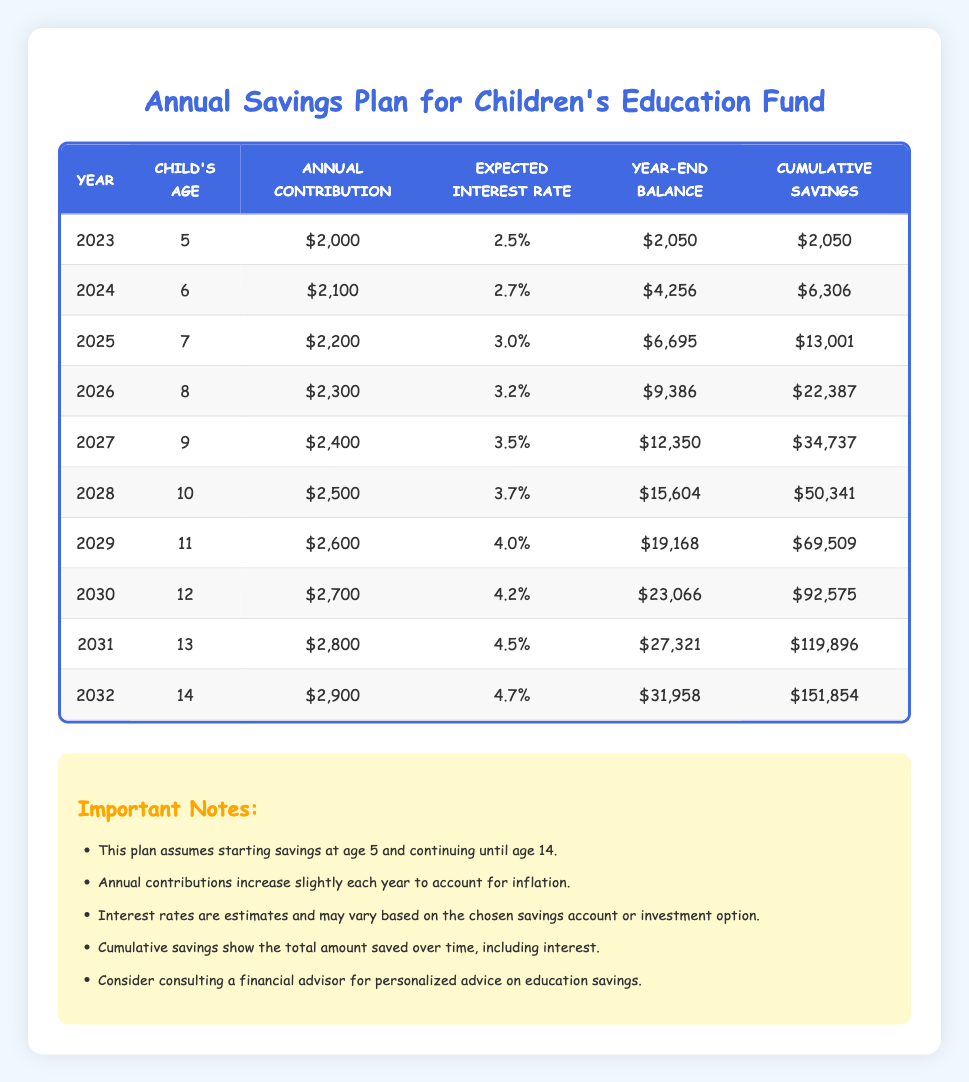What is the child's age in 2027? In the table, the row for the year 2027 shows the child's age is listed as 9.
Answer: 9 What is the cumulative savings in 2028? The cumulative savings for the year 2028 is directly provided in the table, which states it as 50,341.
Answer: 50,341 How much did the annual contribution increase from 2023 to 2024? The annual contribution in 2023 is 2,000, and in 2024 it is 2,100. The difference is 2,100 - 2,000 = 100.
Answer: 100 What is the expected interest rate for 2031? The expected interest rate for the year 2031 is given in the table as 4.5%.
Answer: 4.5% What is the cumulative savings for the year 2032 compared to that of 2026? The cumulative savings for 2032 is 151,854 and for 2026 it is 22,387. The difference is 151,854 - 22,387 = 129,467.
Answer: 129,467 Did the annual contribution always increase each year? By reviewing the annual contributions shown in the table for each year (2,000 to 2,900), we find that each value is greater than the previous, confirming that the contributions always increased.
Answer: Yes What is the total expected interest rate from 2023 to 2032? To find the total expected interest rates, we need to sum up the rates from the table: 2.5 + 2.7 + 3.0 + 3.2 + 3.5 + 3.7 + 4.0 + 4.2 + 4.5 + 4.7 = 36.0%.
Answer: 36.0% What was the year-end balance in 2029? In the 2029 row of the table, the year-end balance is listed as 19,168.
Answer: 19,168 How much did the year-end balance increase from 2025 to 2026? For 2025, the year-end balance is 6,695, and for 2026, it is 9,386. The increase is 9,386 - 6,695 = 2,691.
Answer: 2,691 Which year had the highest annual contribution, and how much was it? The highest annual contribution is seen in 2032, where it is 2,900.
Answer: 2032, 2,900 